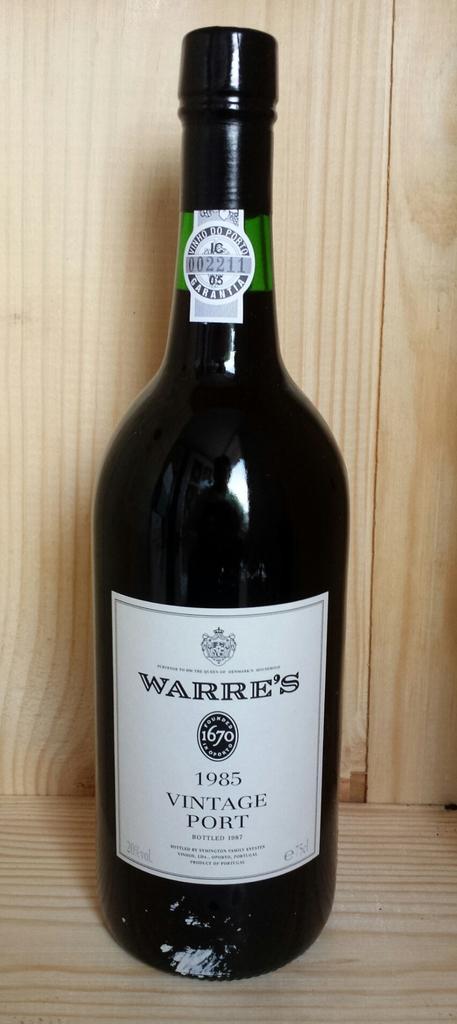What year was this wine made?
Ensure brevity in your answer.  1985. 